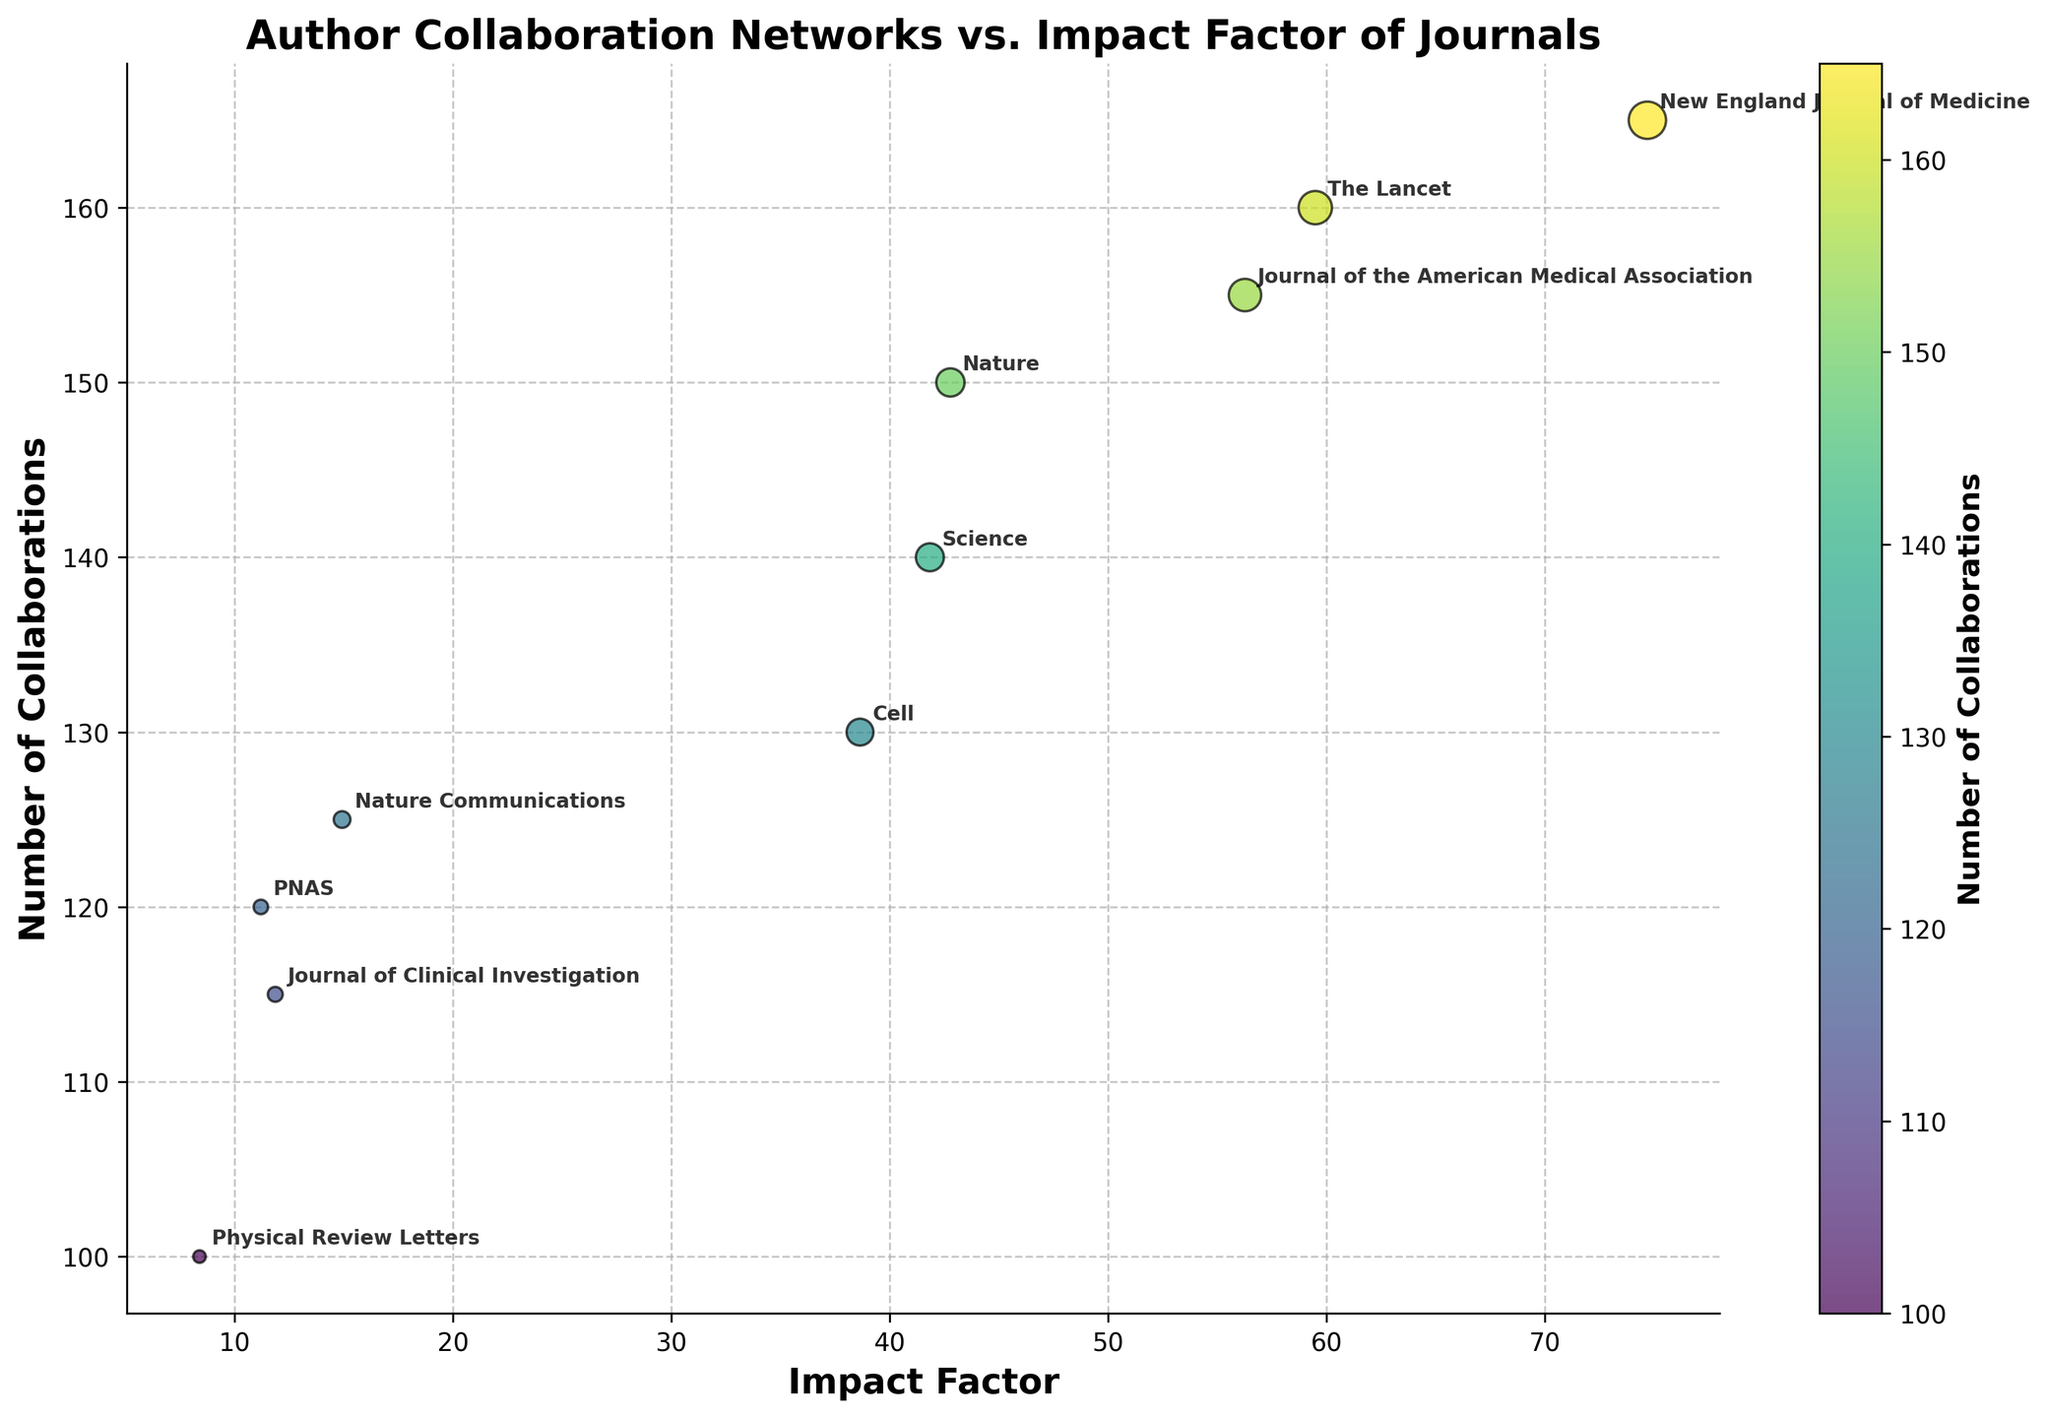What is the title of the figure? The title is an important element situated at the top of the figure that summarizes what the plot is about.
Answer: "Author Collaboration Networks vs. Impact Factor of Journals" How many data points are there in the figure? Each data point corresponds to a journal and is represented by a scatter point on the plot. By counting all the scatter points, we determine the total number of data points.
Answer: 10 Which journal has the highest impact factor and what value is it? By identifying the highest point on the x-axis labeled "Impact Factor" and checking its coordinate, we find the journal with the highest impact factor.
Answer: "New England Journal of Medicine" with 74.70 What is the color representing in the plot? The color coding element in the figure is associated with the color bar, which indicates what the color gradient stands for.
Answer: "Number of Collaborations" How many more collaborations does "New England Journal of Medicine" have compared to "Physical Review Letters"? Fetch the 'Number of Collaborations' for both journals (165 for New England Journal of Medicine and 100 for Physical Review Letters) and calculate the difference. 165 - 100 = 65.
Answer: 65 Which journal has the lowest number of collaborations and what is its impact factor? Locate the marker with the lowest color intensity, find the corresponding journal, and check its position on the x-axis for its impact factor.
Answer: "Physical Review Letters" with an impact factor of 8.39 Is there a general trend between the number of collaborations and the impact factor? By observing the scatter plot, determine if an increase in one variable correlates with an increase in the other. The general trend suggests a positive correlation since higher impact factors correspond to a larger number of collaborations.
Answer: Yes, there is a positive correlation How does the number of collaborations for "The Lancet" compare with that of "Nature"? By checking the 'Number of Collaborations' values for both journals (160 for The Lancet and 150 for Nature), compare which is higher.
Answer: "The Lancet" has 10 more collaborations than "Nature" Identify two journals with similar number of collaborations but different impact factors and state their values. Look for journals whose markers are at a close vertical distance (similar 'Number of Collaborations') but different horizontal distances (varying 'Impact Factors'). "Nature" and "Science" both have approximately similar collaborations (150 and 140), but their impact factors (Nature: 42.78, Science: 41.84) are slightly different.
Answer: "Nature" (42.78 impact factor) and "Science" (41.84 impact factor) What can you infer about the relationship between impact factor and number of collaborations based on the annotated journal positions in the plot? Examine the plot and make inferences based on overall trends and positions of journals annotated on the chart. Journals with higher impact factors tend to have more collaborations. This inference is supported by the positions of journals like "New England Journal of Medicine," "The Lancet," and "Journal of the American Medical Association" on the right side and top of the plot.
Answer: High impact factors correlate with more collaborations 